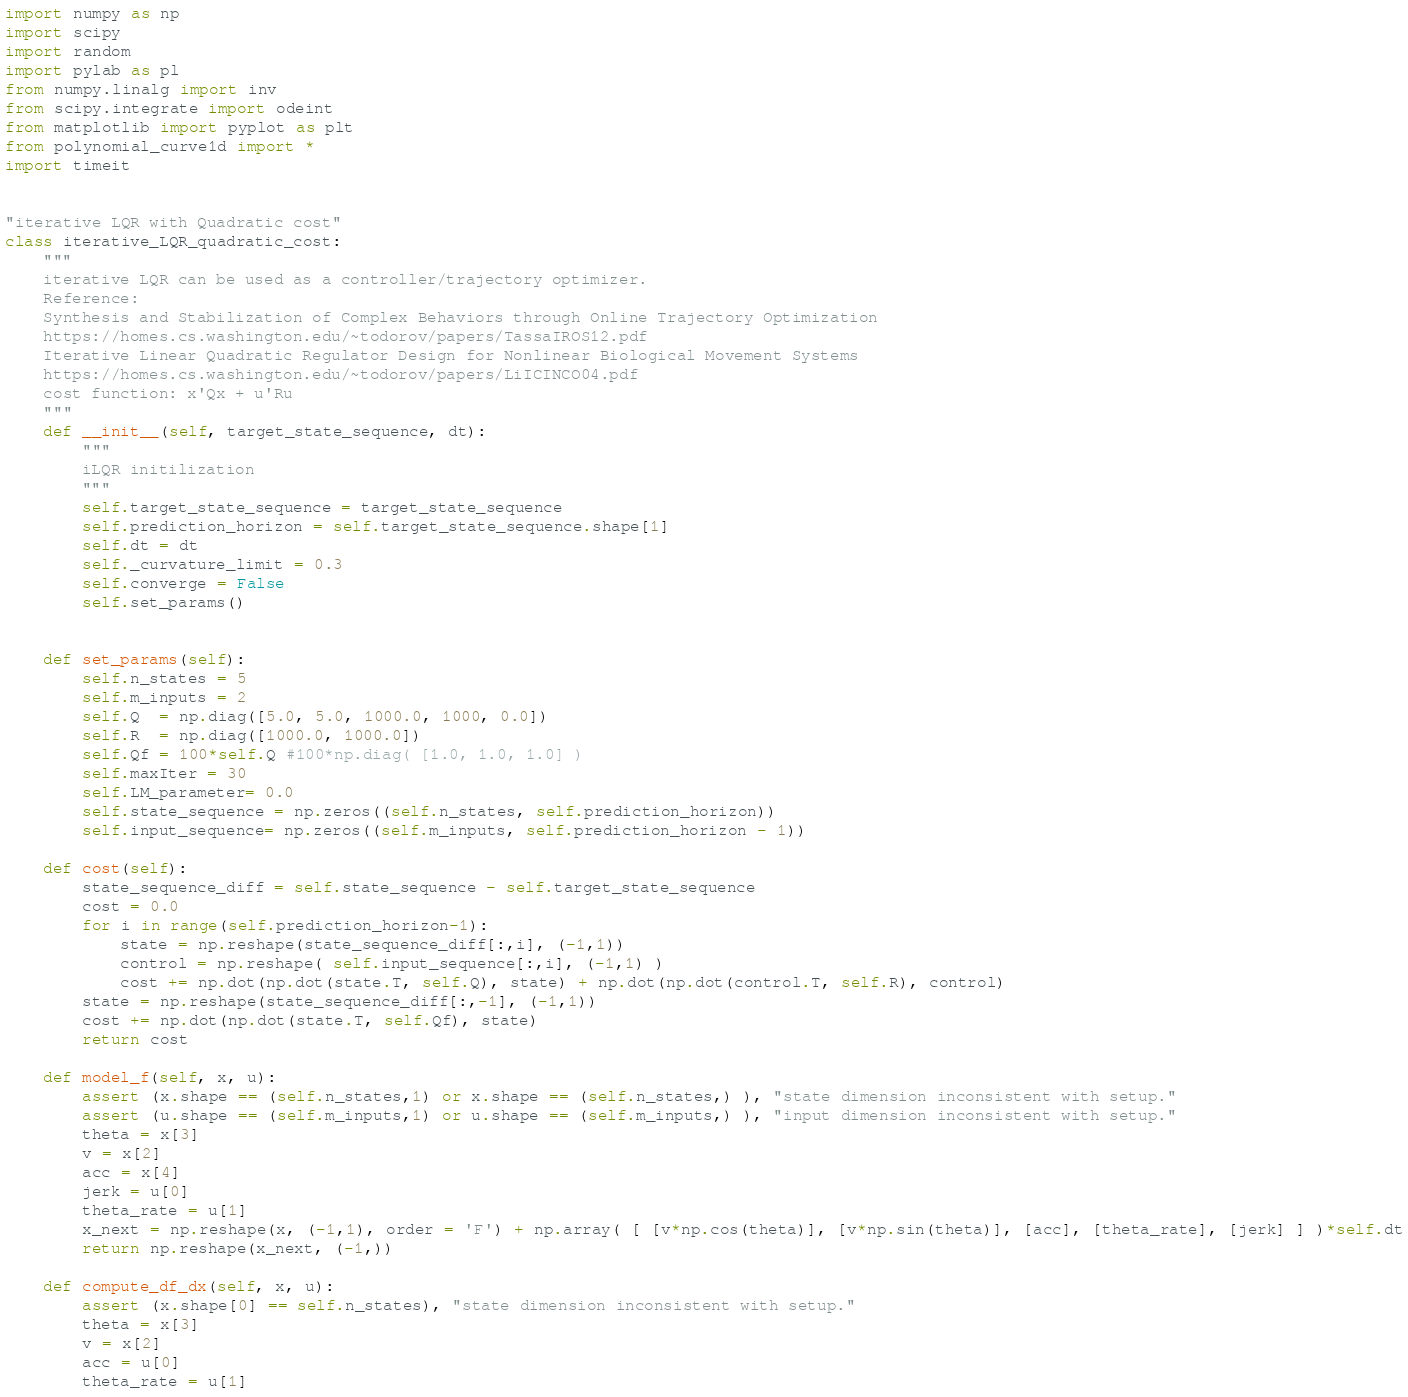Convert code to text. <code><loc_0><loc_0><loc_500><loc_500><_Python_>import numpy as np
import scipy
import random
import pylab as pl
from numpy.linalg import inv
from scipy.integrate import odeint
from matplotlib import pyplot as plt
from polynomial_curve1d import *
import timeit


"iterative LQR with Quadratic cost"
class iterative_LQR_quadratic_cost:
    """
    iterative LQR can be used as a controller/trajectory optimizer.
    Reference:
    Synthesis and Stabilization of Complex Behaviors through Online Trajectory Optimization
    https://homes.cs.washington.edu/~todorov/papers/TassaIROS12.pdf
    Iterative Linear Quadratic Regulator Design for Nonlinear Biological Movement Systems
    https://homes.cs.washington.edu/~todorov/papers/LiICINCO04.pdf
    cost function: x'Qx + u'Ru
    """
    def __init__(self, target_state_sequence, dt):
        """
        iLQR initilization
        """
        self.target_state_sequence = target_state_sequence
        self.prediction_horizon = self.target_state_sequence.shape[1]
        self.dt = dt
        self._curvature_limit = 0.3
        self.converge = False
        self.set_params()
        

    def set_params(self):
        self.n_states = 5
        self.m_inputs = 2
        self.Q  = np.diag([5.0, 5.0, 1000.0, 1000, 0.0])
        self.R  = np.diag([1000.0, 1000.0])
        self.Qf = 100*self.Q #100*np.diag( [1.0, 1.0, 1.0] )
        self.maxIter = 30
        self.LM_parameter= 0.0
        self.state_sequence = np.zeros((self.n_states, self.prediction_horizon))
        self.input_sequence= np.zeros((self.m_inputs, self.prediction_horizon - 1))

    def cost(self):
        state_sequence_diff = self.state_sequence - self.target_state_sequence
        cost = 0.0
        for i in range(self.prediction_horizon-1):
            state = np.reshape(state_sequence_diff[:,i], (-1,1))
            control = np.reshape( self.input_sequence[:,i], (-1,1) )
            cost += np.dot(np.dot(state.T, self.Q), state) + np.dot(np.dot(control.T, self.R), control)
        state = np.reshape(state_sequence_diff[:,-1], (-1,1))
        cost += np.dot(np.dot(state.T, self.Qf), state)
        return cost

    def model_f(self, x, u):
        assert (x.shape == (self.n_states,1) or x.shape == (self.n_states,) ), "state dimension inconsistent with setup."
        assert (u.shape == (self.m_inputs,1) or u.shape == (self.m_inputs,) ), "input dimension inconsistent with setup."
        theta = x[3]
        v = x[2]
        acc = x[4]
        jerk = u[0]
        theta_rate = u[1]
        x_next = np.reshape(x, (-1,1), order = 'F') + np.array( [ [v*np.cos(theta)], [v*np.sin(theta)], [acc], [theta_rate], [jerk] ] )*self.dt
        return np.reshape(x_next, (-1,))

    def compute_df_dx(self, x, u):
        assert (x.shape[0] == self.n_states), "state dimension inconsistent with setup."
        theta = x[3]
        v = x[2]
        acc = u[0]
        theta_rate = u[1]</code> 